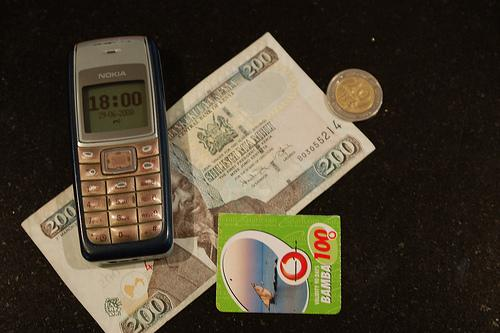How many objects are on the black table? There are five main objects on the black table: a cellphone, paper money, a green card, a coin, and a piece of paper. Elaborate on the appearance of the paper money in the picture. The paper money has a mostly white color with a picture of a man wearing a tie and a gray beard on it. It is a single note with the number 200 and is partly covered by the green card and the coin. What is the primary sentiment of the image? The image primarily invokes a sense of financial themes with objects like paper currency, a coin, and a green card present on a black table. Give a quick summary of the coin resting upon the paper currency. The coin is two-tone, made of metal, and appears gold in some parts. It rests on top of the paper money and is close to the number 200. Evaluate the quality of the image based on the information provided about the objects in the image. The image seems to be of high quality, as it provides clear and detailed descriptions of objects like the cellphone, paper money, green card, and coin, including their colors, dimensions, and text on them. Describe any complex reasoning that could be applied to understand the objects in the image. A complex reasoning analysis could explore the relationship between the objects in terms of financial transactions, such as payment methods, value, currency exchanges, and how the cellphone might be involved in communication, planning, or digital transactions. Analyze the interaction between the various objects in the image. The paper money lays partly under the green card and the coin, the coin is on top of the paper money, and the cellphone is nearby, giving the impression of financial transactions or communication. What is the primary type of object shown in the image? The primary objects in the image are a black table, a cellphone, paper money, a green card, and a coin. Can you provide a brief description of the cell phone present in the image? The cell phone is an old gray and black Nokia phone with buttons, a screen displaying the time 1800 in military format, and the word "Nokia" written on it. Enumerate the details of the green card visible in the image. The green card has the words "Central Bank of Kenya," the number 100, the word "Bamba," and the red number "i00" on it. What attribute describes the material of the table surface? The surface is black. Identify the green card and the gold coin in the image. Green Card (X:216 Y:211 Width:127 Height:127); Gold Coin (X:324 Y:55 Width:62 Height:62) Is the image of high quality? The image quality is moderate. Could you point out the small antique pocket watch resting beside the gold coin? Observe its intricate design. There is no mention of any pocket watch, antique, or otherwise in the information provided. This instruction falsely implies the presence of a non-existent item with a descriptive and captivating detail to mislead the reader. Identify the number on the bottom right corner of the image. The number is 200. Describe the interaction between the coin and paper money. Coin money is on top of paper money. Look for a mysterious blue key hidden somewhere on the table. It is said that it opens a secret door. There are no mentions of any key, especially a blue one, in the provided information. This instruction falsely suggests a hidden item to be found, which is not present in the image. What kind of phone can you spot in the image? An old Nokia phone. Find anomalies in the image. Numbers have faded off the buttons on the phone. Read the words written on the green card. "Central Bank of Kenya" and "Bamba 100" are written on it. Identify the colorful painting of a tree visible in the background of the image. What kind of tree do you think it is? There is no reference to any painting in the provided details, let alone a colorful tree painting. This instruction fabricates an object that doesn't exist within the image, leading the reader to search for something that isn't there. Can you find a purple cat wearing a hat? Make sure you don't miss the whiskers! There is no mention of any cat, let alone a purple one with a hat, in the details provided. This instruction purposefully creates an illusion that such an object exists, when it does not. What color are the buttons on the cell phone? The buttons appear copper colored. Spot the tiny red umbrella hidden underneath the green card. Isn't it peculiar how it's there? The details shared do not include any mention of a red umbrella, especially one underneath the green card. This instruction suggests an unusual object is present when it's not, creating a misleading scenario. What color is the table in the image? The table is black. What is the relationship between the paper money and the green card? Paper money lays under the green card. Describe the man on the paper currency. The man has a gray beard, wearing a suit and a tie. What is the denomination of the paper note? The paper note is a 200 note. Where is the steaming cup of coffee next to the cell phone? Notice the frothy foam art on top. There is no mention of any cup of coffee, let alone one with foam art, in the given details. This instruction directs attention to a nonexistent object with a specific, vivid detail to mislead the reader. Segment the image of the sailboat and the cell phone. Sailboat (X:245 Y:278 Width:34 Height:34); Cell Phone (X:50 Y:22 Width:142 Height:142) Is there any sentiment portrayed in the image? Neutral sentiment. Identify the location of the sailboat in the image. The sailboat is positioned at X:245 Y:278 with Width:34 Height:34. Describe the coin in the image. The coin is two-tone and made of metal. Does the cell phone show any text or symbols? Yes, the cell phone shows the time in military (1800) and the name Nokia. How many buttons are there on the cell phone? Multiple buttons. 